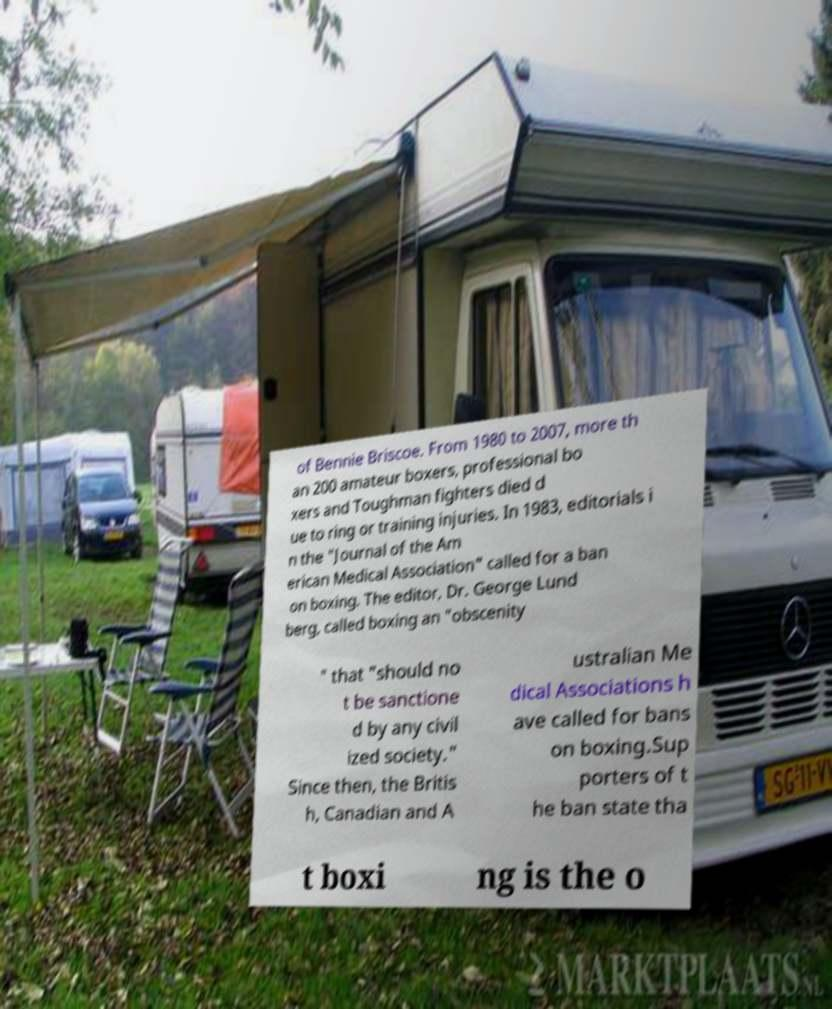Can you read and provide the text displayed in the image?This photo seems to have some interesting text. Can you extract and type it out for me? of Bennie Briscoe. From 1980 to 2007, more th an 200 amateur boxers, professional bo xers and Toughman fighters died d ue to ring or training injuries. In 1983, editorials i n the "Journal of the Am erican Medical Association" called for a ban on boxing. The editor, Dr. George Lund berg, called boxing an "obscenity " that "should no t be sanctione d by any civil ized society." Since then, the Britis h, Canadian and A ustralian Me dical Associations h ave called for bans on boxing.Sup porters of t he ban state tha t boxi ng is the o 